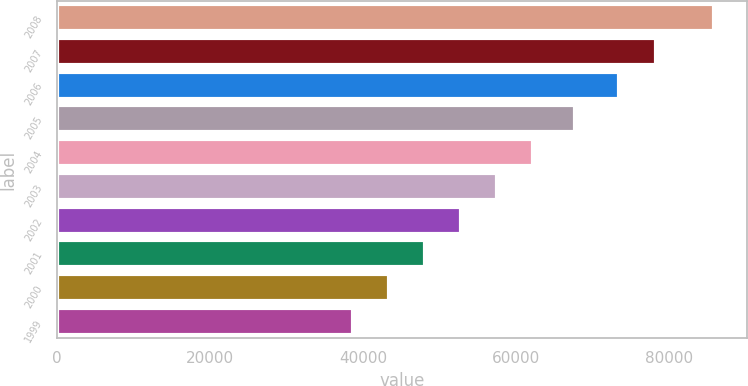Convert chart. <chart><loc_0><loc_0><loc_500><loc_500><bar_chart><fcel>2008<fcel>2007<fcel>2006<fcel>2005<fcel>2004<fcel>2003<fcel>2002<fcel>2001<fcel>2000<fcel>1999<nl><fcel>85835<fcel>78348<fcel>73493<fcel>67737<fcel>62243.5<fcel>57525.2<fcel>52806.9<fcel>48088.6<fcel>43370.3<fcel>38652<nl></chart> 